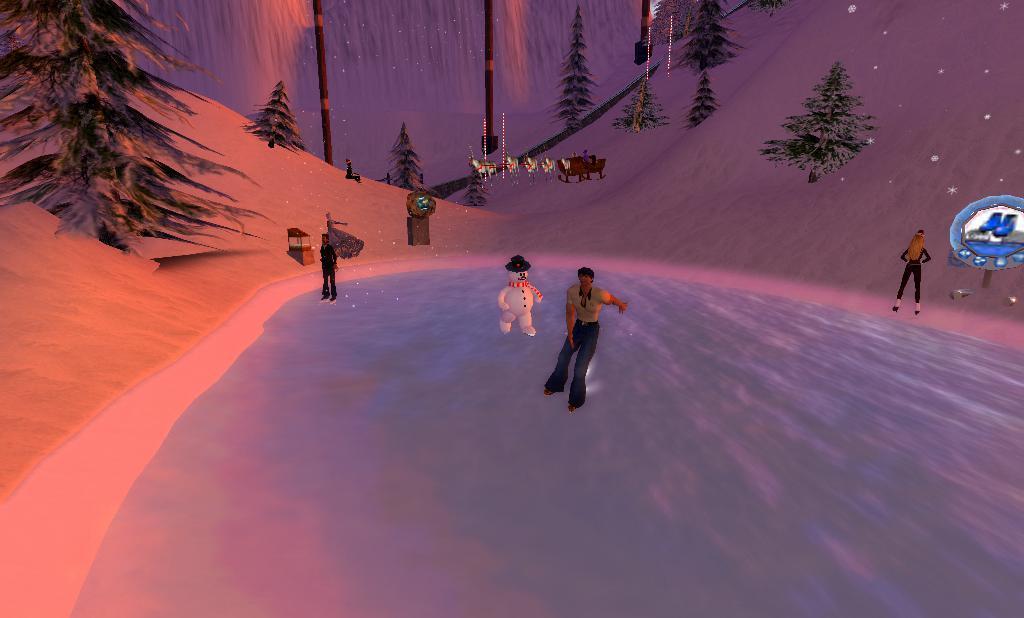Please provide a concise description of this image. In the picture I can see animation of people, the snowman, trees, the snow, wooden poles and mountains. I can also see animation of animals and some other objects. 